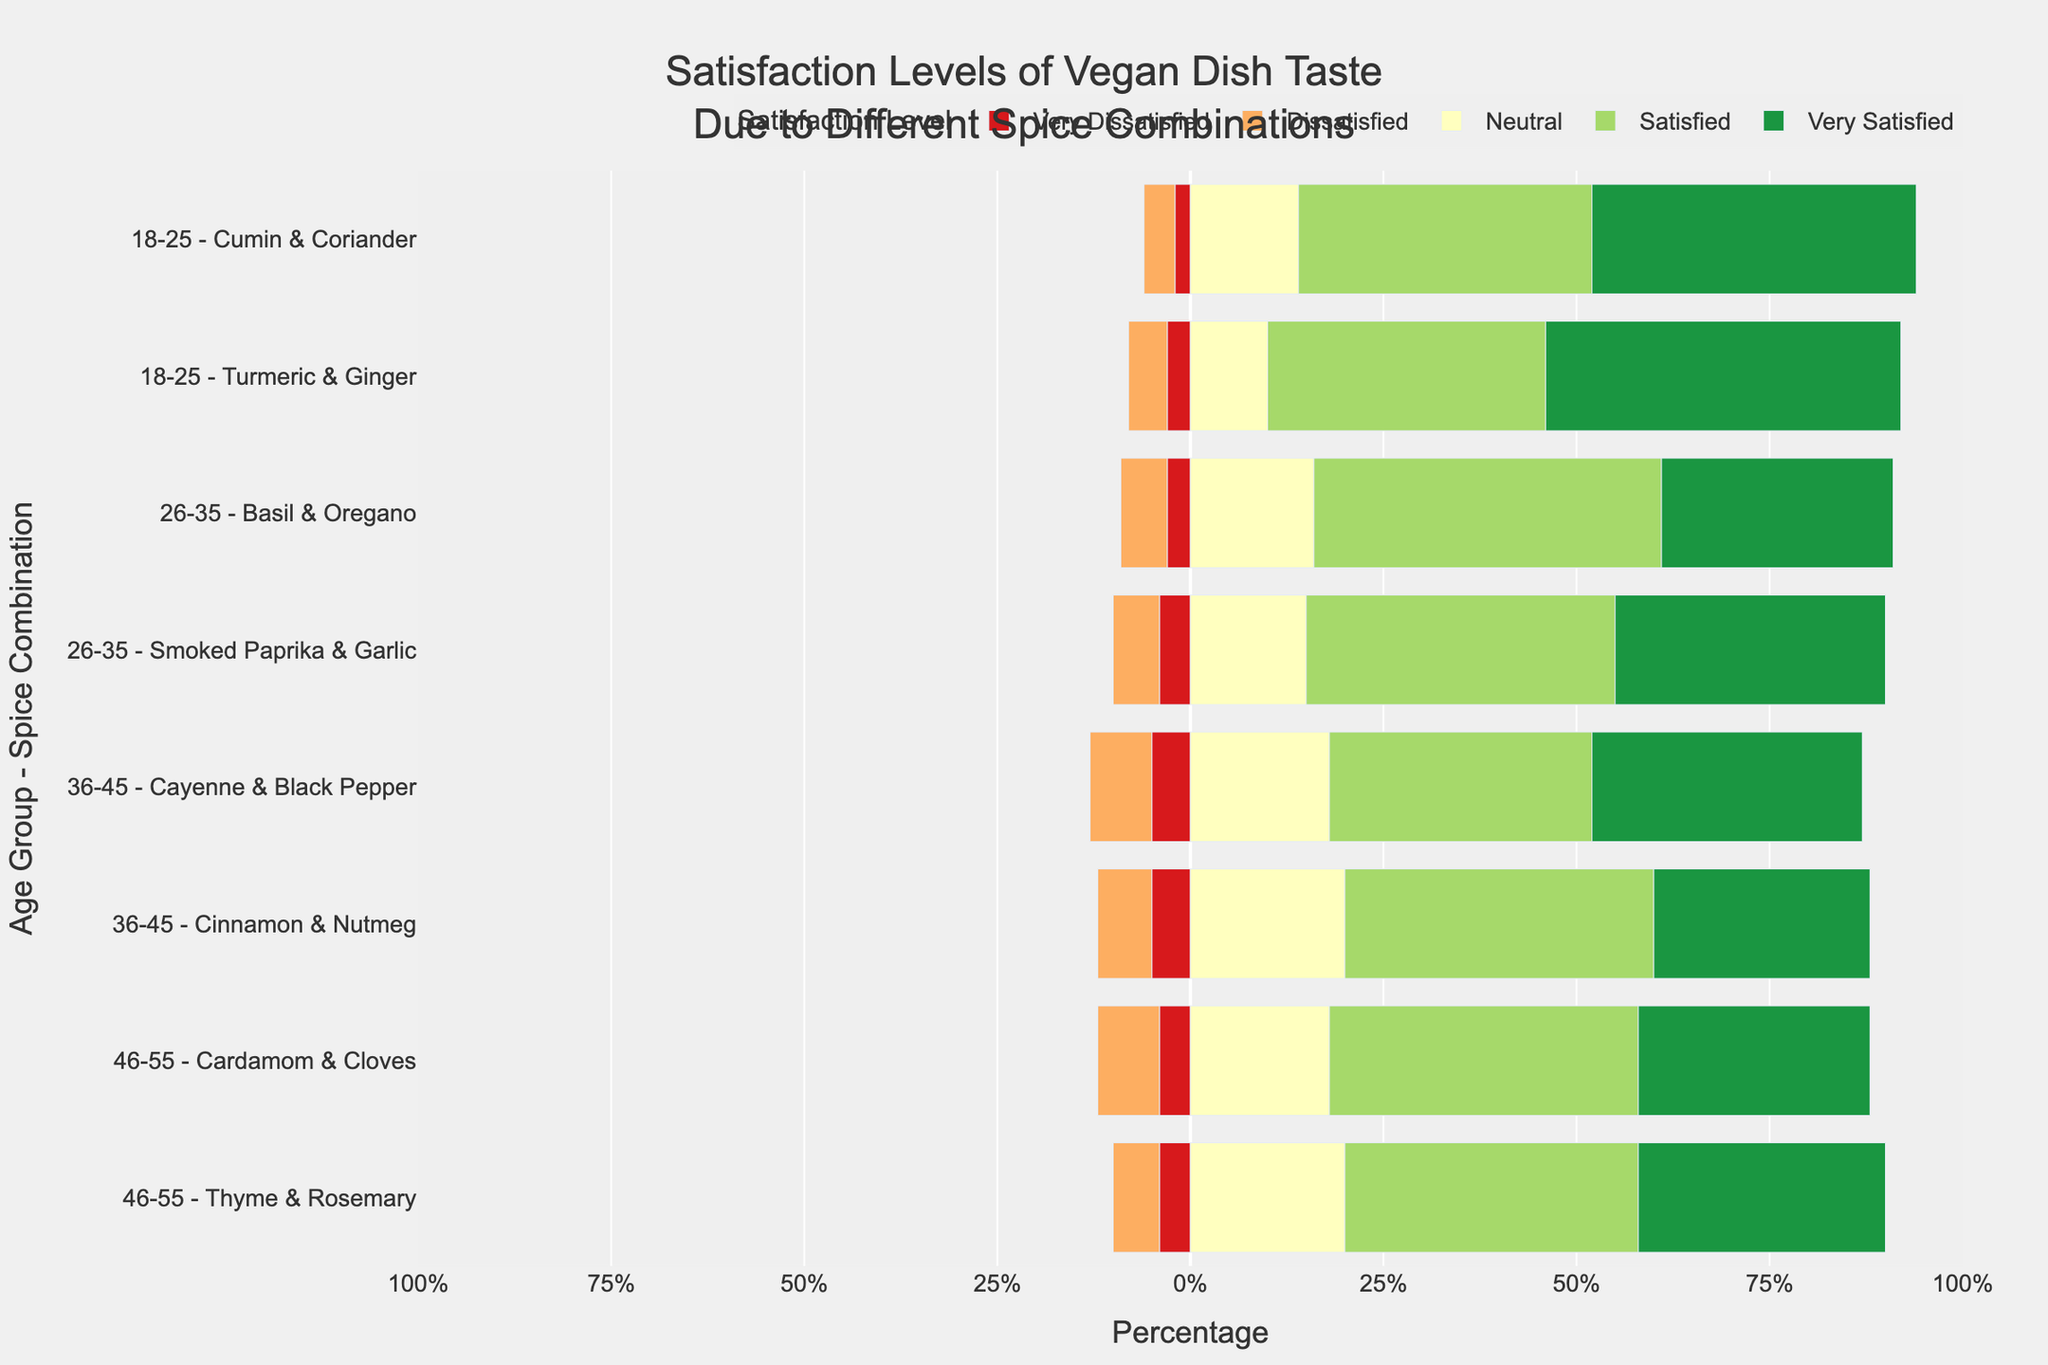Which age group - spice combination has the highest percentage of "Very Satisfied"? First, identify the bars with the "Very Satisfied" satisfaction level. Next, compare the heights of these bars to find the maximum. The group "18-25 - Turmeric & Ginger" has the highest percentage of "Very Satisfied" with 46%.
Answer: 18-25 - Turmeric & Ginger What is the percentage difference in "Satisfied" between "26-35 - Basil & Oregano" and "36-45 - Cayenne & Black Pepper"? Identify and subtract the percentage of "Satisfied" for "36-45 - Cayenne & Black Pepper" (34%) from "26-35 - Basil & Oregano" (45%). The difference is 45% - 34% = 11%.
Answer: 11% Which age group - spice combination has the smallest percentage of "Very Dissatisfied"? Locate the bars representing "Very Dissatisfied" and find the one with the smallest height. "18-25 - Cumin & Coriander" has the smallest percentage of "Very Dissatisfied" at 2%.
Answer: 18-25 - Cumin & Coriander How many age group - spice combinations have "Very Satisfied" percentages greater than 30%? Identify the combinations with "Very Satisfied" percentages over 30%. The qualifying combinations are "18-25 - Cumin & Coriander", "18-25 - Turmeric & Ginger", "26-35 - Smoked Paprika & Garlic", "26-35 - Basil & Oregano", "36-45 - Cayenne & Black Pepper", "46-55 - Thyme & Rosemary", and "46-55 - Cardamom & Cloves". There are 7 combinations in total.
Answer: 7 Which spice combination within the 36-45 age group received the higher "Neutral" percentage? Compare the "Neutral" percentages for "Cinnamon & Nutmeg" (20%) and "Cayenne & Black Pepper" (18%). "Cinnamon & Nutmeg" has a higher "Neutral" percentage.
Answer: Cinnamon & Nutmeg 